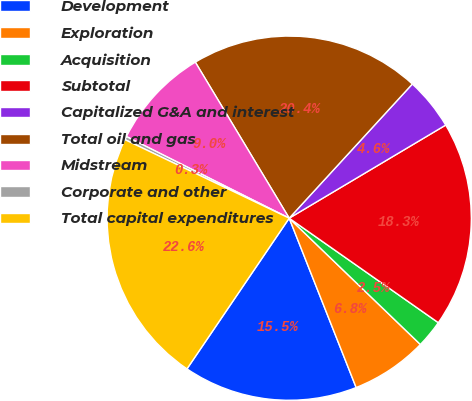Convert chart to OTSL. <chart><loc_0><loc_0><loc_500><loc_500><pie_chart><fcel>Development<fcel>Exploration<fcel>Acquisition<fcel>Subtotal<fcel>Capitalized G&A and interest<fcel>Total oil and gas<fcel>Midstream<fcel>Corporate and other<fcel>Total capital expenditures<nl><fcel>15.48%<fcel>6.81%<fcel>2.47%<fcel>18.27%<fcel>4.64%<fcel>20.44%<fcel>8.98%<fcel>0.3%<fcel>22.61%<nl></chart> 